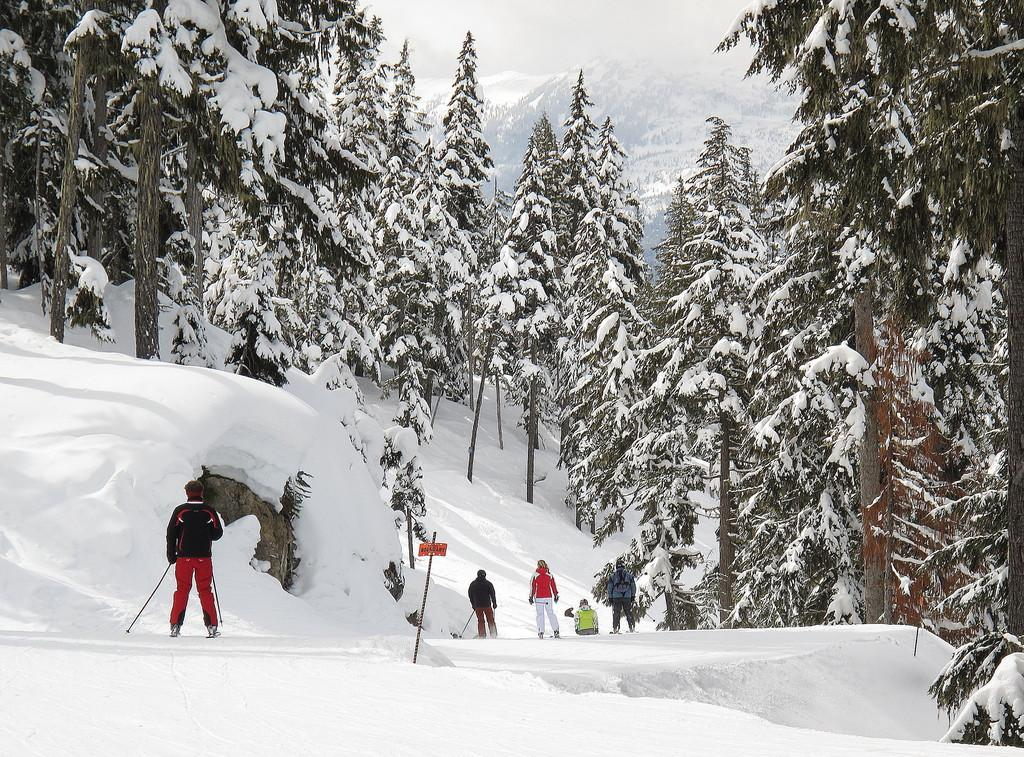What are the people in the image doing? The people in the image are skating. On what surface are the people skating? The people are skating on snow. What can be seen in the background of the image? There are trees in the background of the image. How is the snow affecting the trees in the image? The trees have snow on them. What type of destruction can be seen in the alley in the image? There is no alley or destruction present in the image; it features people skating on snow with trees in the background. 